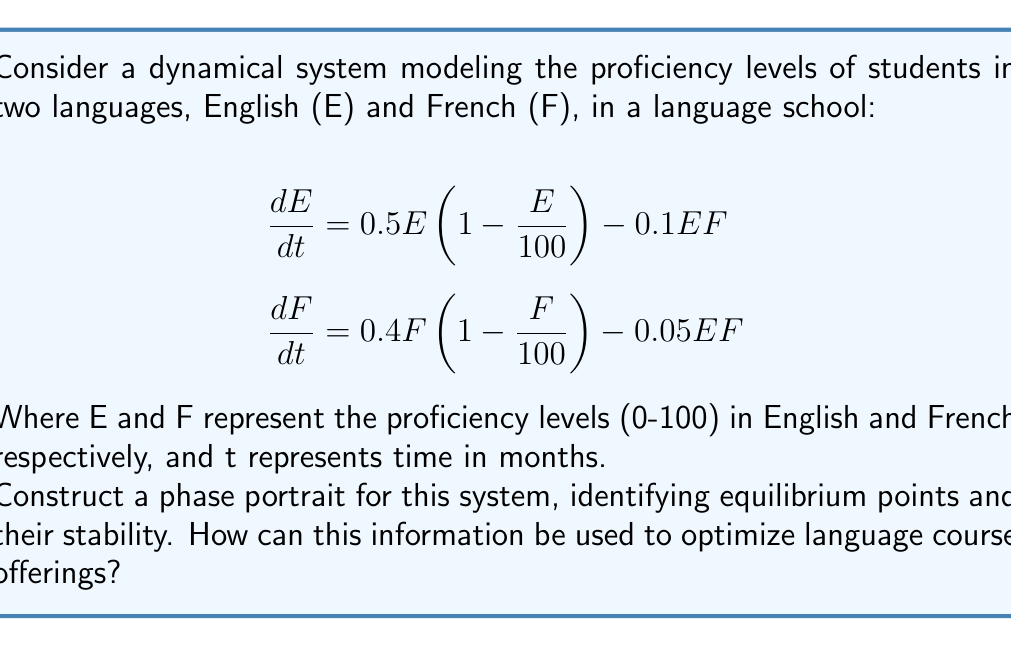Could you help me with this problem? 1. Find equilibrium points:
   Set $\frac{dE}{dt} = 0$ and $\frac{dF}{dt} = 0$
   
   a) $(E,F) = (0,0)$
   b) $(E,F) = (100,0)$
   c) $(E,F) = (0,100)$
   d) Solving numerically, we find $(E,F) \approx (83.33, 66.67)$

2. Analyze stability:
   Calculate the Jacobian matrix:
   $$J = \begin{bmatrix}
   0.5 - E/50 - 0.1F & -0.1E \\
   -0.05F & 0.4 - F/50 - 0.05E
   \end{bmatrix}$$

   Evaluate at each equilibrium point:
   
   a) $(0,0)$: Unstable node
   b) $(100,0)$: Saddle point
   c) $(0,100)$: Saddle point
   d) $(83.33, 66.67)$: Stable node

3. Sketch nullclines:
   $\frac{dE}{dt} = 0$ when $E = 0$ or $F = 5(1 - E/100)$
   $\frac{dF}{dt} = 0$ when $F = 0$ or $F = 8(1 - E/20)$

4. Draw vector field:
   Use arrows to indicate direction and magnitude of change at various points.

5. Interpret results:
   - Students starting with no knowledge (0,0) will improve in both languages.
   - There's a tendency towards balanced proficiency (stable node at 83.33, 66.67).
   - Focusing solely on one language is unstable and will lead to improvement in the other.

6. Optimize course offerings:
   - Offer balanced courses to reach the stable equilibrium.
   - Provide extra support for students far from the stable point.
   - Create specialized courses for students near saddle points to prevent regression.
Answer: Phase portrait shows 4 equilibria: unstable (0,0), saddle points (100,0) and (0,100), stable (83.33, 66.67). Optimal strategy: balanced courses, targeted support. 